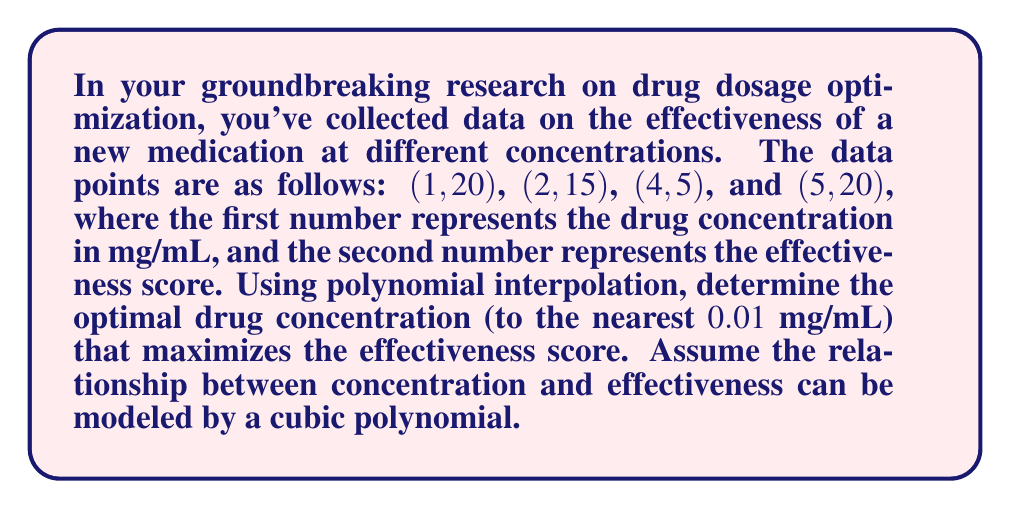Can you solve this math problem? To solve this problem, we'll use Lagrange polynomial interpolation to find the cubic polynomial that fits the given data points, then find the maximum of this function.

Step 1: Construct the Lagrange polynomial
The Lagrange polynomial for n+1 points $(x_i, y_i)$ is given by:

$$L(x) = \sum_{i=0}^n y_i \prod_{j=0, j \neq i}^n \frac{x - x_j}{x_i - x_j}$$

For our data points:
$$(x_0, y_0) = (1, 20)$$
$$(x_1, y_1) = (2, 15)$$
$$(x_2, y_2) = (4, 5)$$
$$(x_3, y_3) = (5, 20)$$

Step 2: Calculate the Lagrange polynomial
$$L(x) = 20\frac{(x-2)(x-4)(x-5)}{(1-2)(1-4)(1-5)} + 15\frac{(x-1)(x-4)(x-5)}{(2-1)(2-4)(2-5)} + 5\frac{(x-1)(x-2)(x-5)}{(4-1)(4-2)(4-5)} + 20\frac{(x-1)(x-2)(x-4)}{(5-1)(5-2)(5-4)}$$

Simplifying, we get:
$$L(x) = \frac{5}{6}x^3 - \frac{35}{6}x^2 + \frac{85}{6}x - 10$$

Step 3: Find the maximum of the polynomial
To find the maximum, we need to find where the derivative of $L(x)$ equals zero:

$$L'(x) = \frac{5}{2}x^2 - \frac{35}{3}x + \frac{85}{6}$$

Set $L'(x) = 0$ and solve:

$$\frac{5}{2}x^2 - \frac{35}{3}x + \frac{85}{6} = 0$$

Using the quadratic formula, we get:

$$x = \frac{\frac{35}{3} \pm \sqrt{(\frac{35}{3})^2 - 4(\frac{5}{2})(\frac{85}{6})}}{2(\frac{5}{2})}$$

Simplifying:
$$x \approx 1.27 \text{ or } 3.53$$

Step 4: Determine which solution gives the maximum
Evaluating $L(x)$ at these points:
$$L(1.27) \approx 20.16$$
$$L(3.53) \approx 11.84$$

Therefore, the maximum occurs at $x \approx 1.27$.
Answer: 1.27 mg/mL 